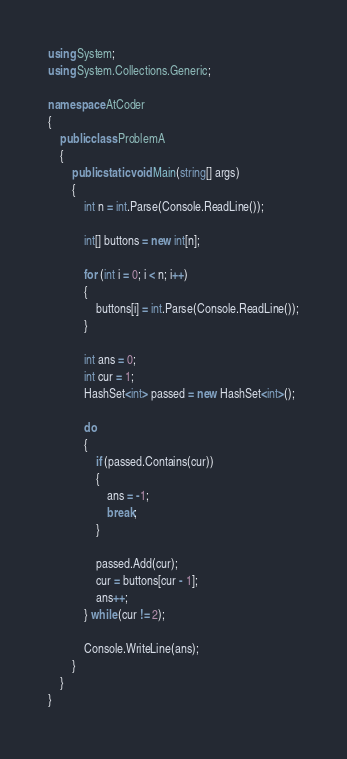<code> <loc_0><loc_0><loc_500><loc_500><_C#_>using System;
using System.Collections.Generic;

namespace AtCoder
{
	public class ProblemA
	{
		public static void Main(string[] args)
		{
			int n = int.Parse(Console.ReadLine());

			int[] buttons = new int[n];

			for (int i = 0; i < n; i++)
			{
				buttons[i] = int.Parse(Console.ReadLine());
			}

			int ans = 0;
			int cur = 1;
			HashSet<int> passed = new HashSet<int>();

			do
			{
				if (passed.Contains(cur))
				{
					ans = -1;
					break;
				}

				passed.Add(cur);
				cur = buttons[cur - 1];
				ans++;
			} while (cur != 2);

			Console.WriteLine(ans);
		}
	}
}
</code> 